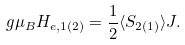<formula> <loc_0><loc_0><loc_500><loc_500>g \mu _ { B } H _ { e , 1 ( 2 ) } = \frac { 1 } { 2 } \langle S _ { 2 ( 1 ) } \rangle J .</formula> 